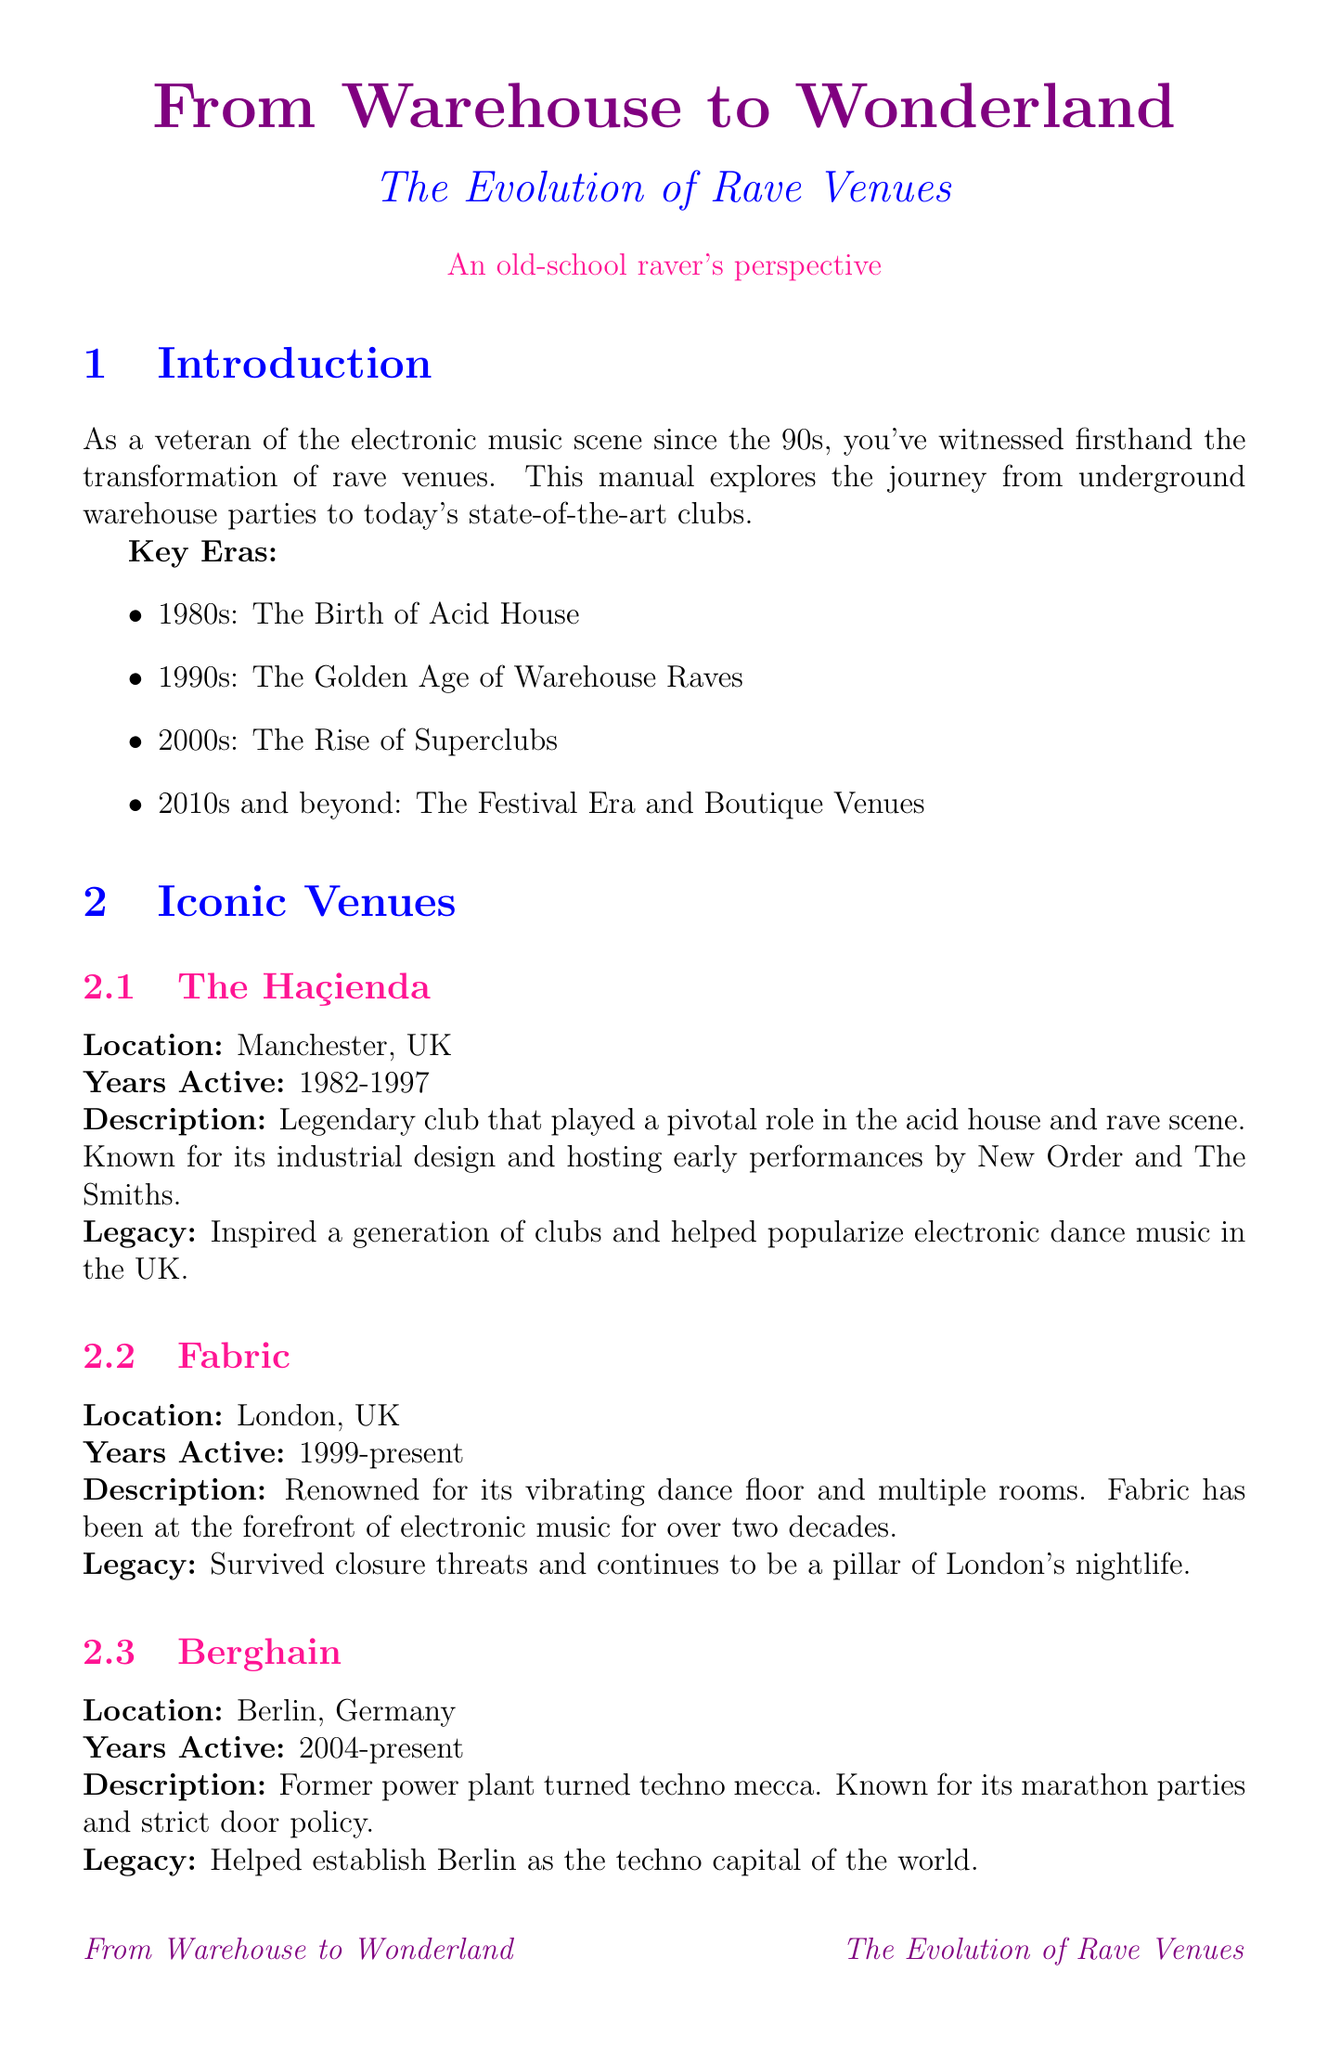What year did The Haçienda close? The Haçienda was active from 1982 to 1997, indicating it closed in 1997.
Answer: 1997 Which city is Fabric located in? Fabric is mentioned as being located in London, UK.
Answer: London, UK What significant trend emerged in the 2000s for sound systems? In the 2000s, venues began using digital mixers and CDJs as part of their sound systems.
Answer: Digital mixers, CDJs What is the primary focus of the warehouse era? The primary focus during the warehouse era was on music and community.
Answer: Music and community Which festival is known for its elaborate stage designs? Tomorrowland is highlighted as a massive electronic music festival known for its elaborate stage designs.
Answer: Tomorrowland How many years was The Haçienda active? The document states The Haçienda was active from 1982 to 1997, which is a span of 15 years.
Answer: 15 years What is one characteristic of modern rave venues? One noted characteristic is the integration of technology, such as RFID wristbands.
Answer: Integration of technology Which venue is described as a “techno mecca”? Berghain is cited as the former power plant turned techno mecca.
Answer: Berghain What significant change in venues is discussed for the future? The document mentions virtual and augmented reality experiences as a future trend in venues.
Answer: Virtual and augmented reality experiences 